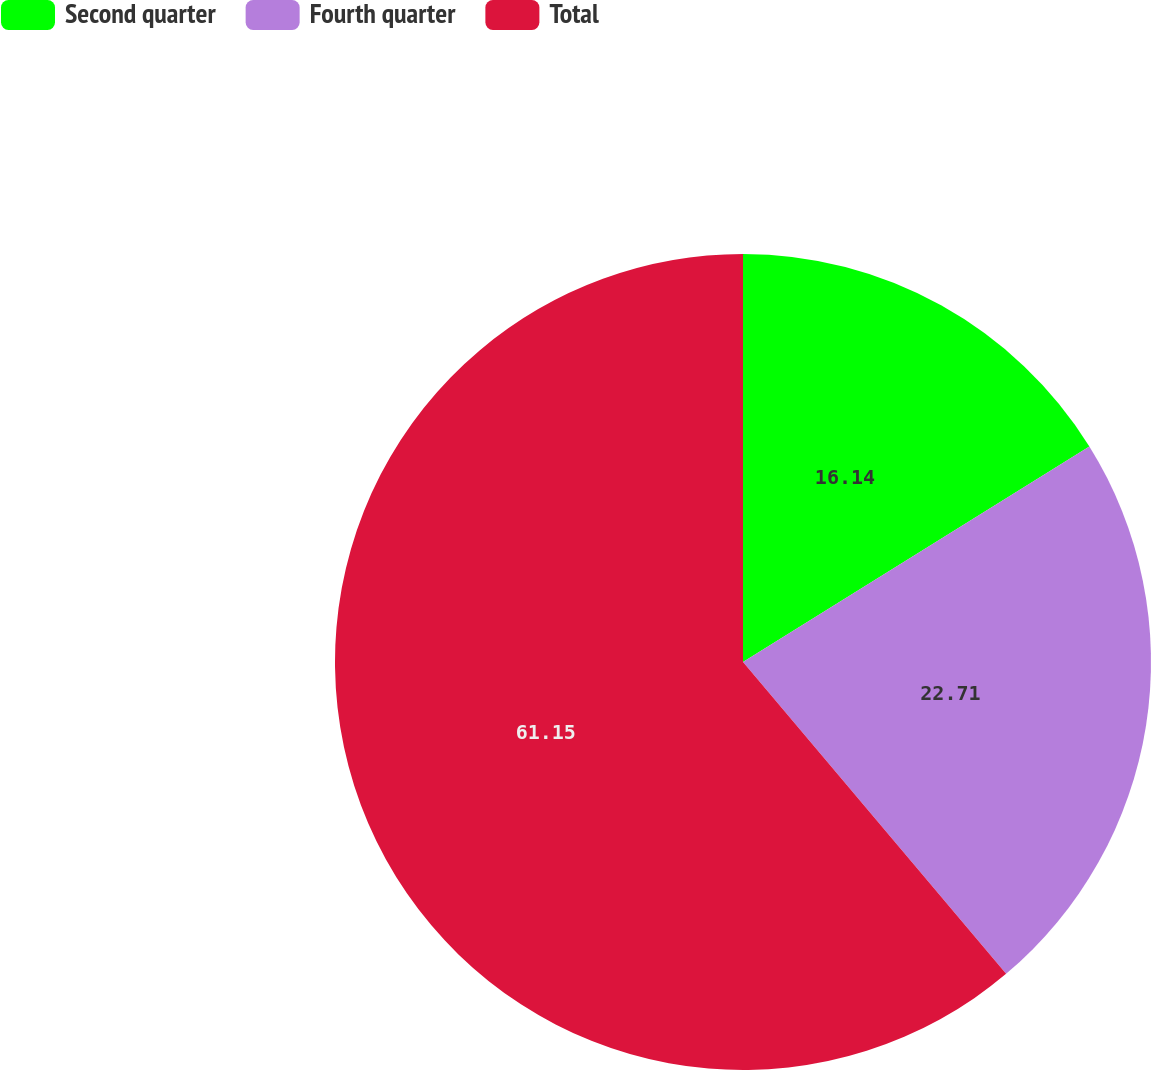<chart> <loc_0><loc_0><loc_500><loc_500><pie_chart><fcel>Second quarter<fcel>Fourth quarter<fcel>Total<nl><fcel>16.14%<fcel>22.71%<fcel>61.16%<nl></chart> 